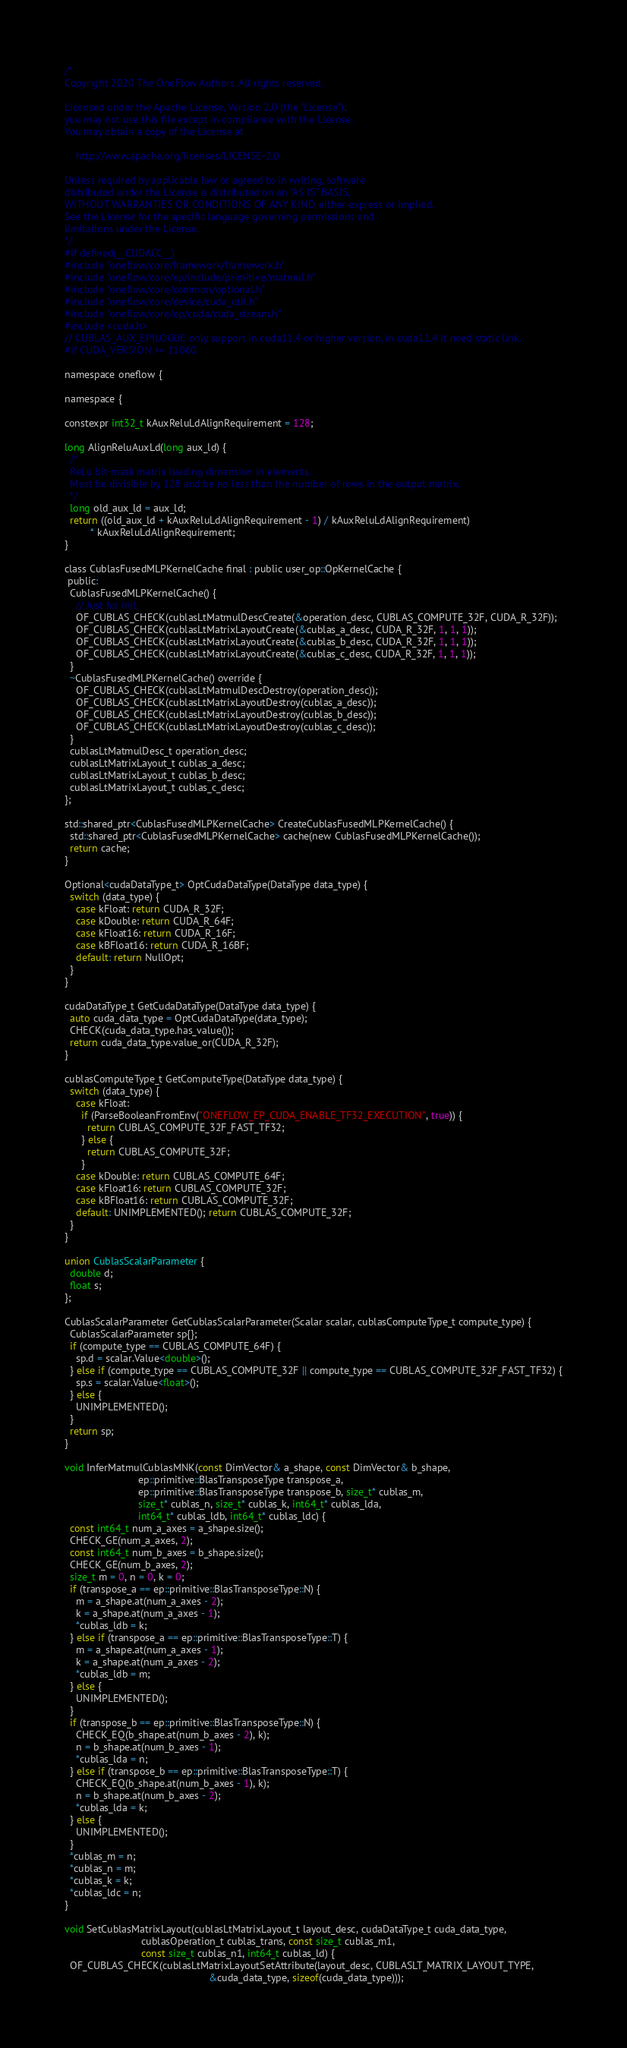Convert code to text. <code><loc_0><loc_0><loc_500><loc_500><_Cuda_>/*
Copyright 2020 The OneFlow Authors. All rights reserved.

Licensed under the Apache License, Version 2.0 (the "License");
you may not use this file except in compliance with the License.
You may obtain a copy of the License at

    http://www.apache.org/licenses/LICENSE-2.0

Unless required by applicable law or agreed to in writing, software
distributed under the License is distributed on an "AS IS" BASIS,
WITHOUT WARRANTIES OR CONDITIONS OF ANY KIND, either express or implied.
See the License for the specific language governing permissions and
limitations under the License.
*/
#if defined(__CUDACC__)
#include "oneflow/core/framework/framework.h"
#include "oneflow/core/ep/include/primitive/matmul.h"
#include "oneflow/core/common/optional.h"
#include "oneflow/core/device/cuda_util.h"
#include "oneflow/core/ep/cuda/cuda_stream.h"
#include <cuda.h>
// CUBLAS_AUX_EPILOGUE only support in cuda11.4 or higher version, in cuda11.4 it need static link.
#if CUDA_VERSION >= 11060

namespace oneflow {

namespace {

constexpr int32_t kAuxReluLdAlignRequirement = 128;

long AlignReluAuxLd(long aux_ld) {
  /*
  ReLu bit-mask matrix leading dimension in elements.
  Must be divisible by 128 and be no less than the number of rows in the output matrix.
  */
  long old_aux_ld = aux_ld;
  return ((old_aux_ld + kAuxReluLdAlignRequirement - 1) / kAuxReluLdAlignRequirement)
         * kAuxReluLdAlignRequirement;
}

class CublasFusedMLPKernelCache final : public user_op::OpKernelCache {
 public:
  CublasFusedMLPKernelCache() {
    // Just for init.
    OF_CUBLAS_CHECK(cublasLtMatmulDescCreate(&operation_desc, CUBLAS_COMPUTE_32F, CUDA_R_32F));
    OF_CUBLAS_CHECK(cublasLtMatrixLayoutCreate(&cublas_a_desc, CUDA_R_32F, 1, 1, 1));
    OF_CUBLAS_CHECK(cublasLtMatrixLayoutCreate(&cublas_b_desc, CUDA_R_32F, 1, 1, 1));
    OF_CUBLAS_CHECK(cublasLtMatrixLayoutCreate(&cublas_c_desc, CUDA_R_32F, 1, 1, 1));
  }
  ~CublasFusedMLPKernelCache() override {
    OF_CUBLAS_CHECK(cublasLtMatmulDescDestroy(operation_desc));
    OF_CUBLAS_CHECK(cublasLtMatrixLayoutDestroy(cublas_a_desc));
    OF_CUBLAS_CHECK(cublasLtMatrixLayoutDestroy(cublas_b_desc));
    OF_CUBLAS_CHECK(cublasLtMatrixLayoutDestroy(cublas_c_desc));
  }
  cublasLtMatmulDesc_t operation_desc;
  cublasLtMatrixLayout_t cublas_a_desc;
  cublasLtMatrixLayout_t cublas_b_desc;
  cublasLtMatrixLayout_t cublas_c_desc;
};

std::shared_ptr<CublasFusedMLPKernelCache> CreateCublasFusedMLPKernelCache() {
  std::shared_ptr<CublasFusedMLPKernelCache> cache(new CublasFusedMLPKernelCache());
  return cache;
}

Optional<cudaDataType_t> OptCudaDataType(DataType data_type) {
  switch (data_type) {
    case kFloat: return CUDA_R_32F;
    case kDouble: return CUDA_R_64F;
    case kFloat16: return CUDA_R_16F;
    case kBFloat16: return CUDA_R_16BF;
    default: return NullOpt;
  }
}

cudaDataType_t GetCudaDataType(DataType data_type) {
  auto cuda_data_type = OptCudaDataType(data_type);
  CHECK(cuda_data_type.has_value());
  return cuda_data_type.value_or(CUDA_R_32F);
}

cublasComputeType_t GetComputeType(DataType data_type) {
  switch (data_type) {
    case kFloat:
      if (ParseBooleanFromEnv("ONEFLOW_EP_CUDA_ENABLE_TF32_EXECUTION", true)) {
        return CUBLAS_COMPUTE_32F_FAST_TF32;
      } else {
        return CUBLAS_COMPUTE_32F;
      }
    case kDouble: return CUBLAS_COMPUTE_64F;
    case kFloat16: return CUBLAS_COMPUTE_32F;
    case kBFloat16: return CUBLAS_COMPUTE_32F;
    default: UNIMPLEMENTED(); return CUBLAS_COMPUTE_32F;
  }
}

union CublasScalarParameter {
  double d;
  float s;
};

CublasScalarParameter GetCublasScalarParameter(Scalar scalar, cublasComputeType_t compute_type) {
  CublasScalarParameter sp{};
  if (compute_type == CUBLAS_COMPUTE_64F) {
    sp.d = scalar.Value<double>();
  } else if (compute_type == CUBLAS_COMPUTE_32F || compute_type == CUBLAS_COMPUTE_32F_FAST_TF32) {
    sp.s = scalar.Value<float>();
  } else {
    UNIMPLEMENTED();
  }
  return sp;
}

void InferMatmulCublasMNK(const DimVector& a_shape, const DimVector& b_shape,
                          ep::primitive::BlasTransposeType transpose_a,
                          ep::primitive::BlasTransposeType transpose_b, size_t* cublas_m,
                          size_t* cublas_n, size_t* cublas_k, int64_t* cublas_lda,
                          int64_t* cublas_ldb, int64_t* cublas_ldc) {
  const int64_t num_a_axes = a_shape.size();
  CHECK_GE(num_a_axes, 2);
  const int64_t num_b_axes = b_shape.size();
  CHECK_GE(num_b_axes, 2);
  size_t m = 0, n = 0, k = 0;
  if (transpose_a == ep::primitive::BlasTransposeType::N) {
    m = a_shape.at(num_a_axes - 2);
    k = a_shape.at(num_a_axes - 1);
    *cublas_ldb = k;
  } else if (transpose_a == ep::primitive::BlasTransposeType::T) {
    m = a_shape.at(num_a_axes - 1);
    k = a_shape.at(num_a_axes - 2);
    *cublas_ldb = m;
  } else {
    UNIMPLEMENTED();
  }
  if (transpose_b == ep::primitive::BlasTransposeType::N) {
    CHECK_EQ(b_shape.at(num_b_axes - 2), k);
    n = b_shape.at(num_b_axes - 1);
    *cublas_lda = n;
  } else if (transpose_b == ep::primitive::BlasTransposeType::T) {
    CHECK_EQ(b_shape.at(num_b_axes - 1), k);
    n = b_shape.at(num_b_axes - 2);
    *cublas_lda = k;
  } else {
    UNIMPLEMENTED();
  }
  *cublas_m = n;
  *cublas_n = m;
  *cublas_k = k;
  *cublas_ldc = n;
}

void SetCublasMatrixLayout(cublasLtMatrixLayout_t layout_desc, cudaDataType_t cuda_data_type,
                           cublasOperation_t cublas_trans, const size_t cublas_m1,
                           const size_t cublas_n1, int64_t cublas_ld) {
  OF_CUBLAS_CHECK(cublasLtMatrixLayoutSetAttribute(layout_desc, CUBLASLT_MATRIX_LAYOUT_TYPE,
                                                   &cuda_data_type, sizeof(cuda_data_type)));</code> 